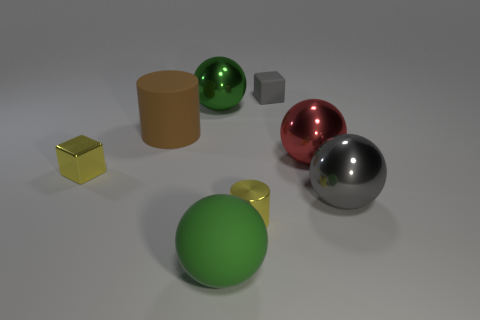Subtract all big gray metal balls. How many balls are left? 3 Subtract all blocks. How many objects are left? 6 Add 1 tiny metal cylinders. How many objects exist? 9 Add 2 tiny yellow cylinders. How many tiny yellow cylinders exist? 3 Subtract all gray balls. How many balls are left? 3 Subtract 0 brown blocks. How many objects are left? 8 Subtract 2 balls. How many balls are left? 2 Subtract all cyan spheres. Subtract all purple cylinders. How many spheres are left? 4 Subtract all brown blocks. How many purple cylinders are left? 0 Subtract all big green balls. Subtract all small things. How many objects are left? 3 